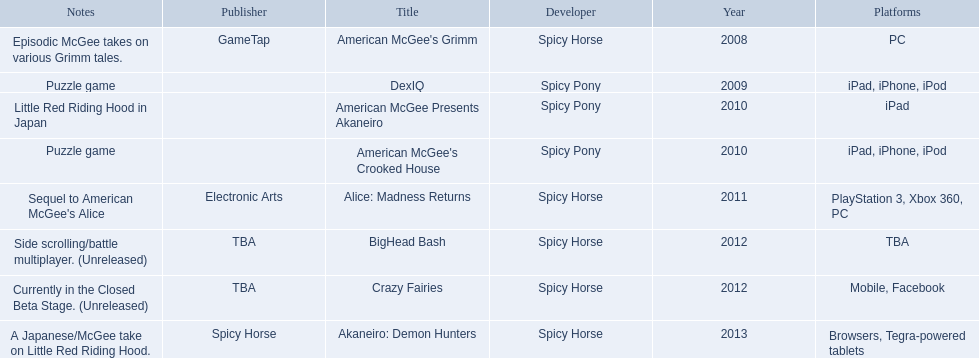What are all of the game titles? American McGee's Grimm, DexIQ, American McGee Presents Akaneiro, American McGee's Crooked House, Alice: Madness Returns, BigHead Bash, Crazy Fairies, Akaneiro: Demon Hunters. Which developer developed a game in 2011? Spicy Horse. Who published this game in 2011 Electronic Arts. What was the name of this published game in 2011? Alice: Madness Returns. 